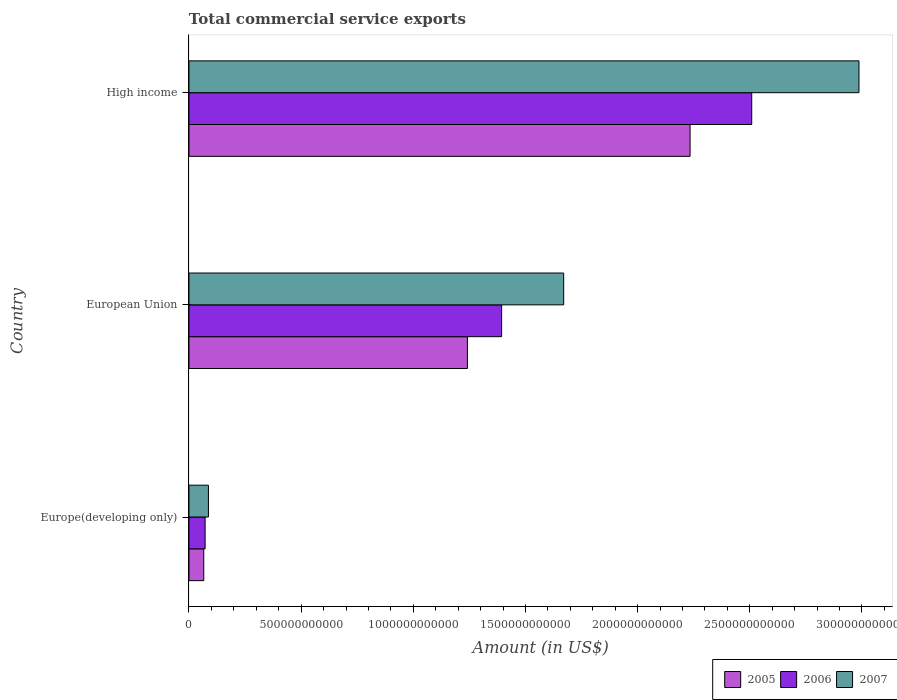Are the number of bars on each tick of the Y-axis equal?
Make the answer very short. Yes. What is the label of the 2nd group of bars from the top?
Make the answer very short. European Union. In how many cases, is the number of bars for a given country not equal to the number of legend labels?
Offer a terse response. 0. What is the total commercial service exports in 2006 in European Union?
Provide a short and direct response. 1.39e+12. Across all countries, what is the maximum total commercial service exports in 2005?
Provide a short and direct response. 2.23e+12. Across all countries, what is the minimum total commercial service exports in 2007?
Your answer should be very brief. 8.67e+1. In which country was the total commercial service exports in 2007 minimum?
Make the answer very short. Europe(developing only). What is the total total commercial service exports in 2006 in the graph?
Offer a very short reply. 3.97e+12. What is the difference between the total commercial service exports in 2005 in Europe(developing only) and that in High income?
Your answer should be compact. -2.17e+12. What is the difference between the total commercial service exports in 2005 in Europe(developing only) and the total commercial service exports in 2007 in High income?
Make the answer very short. -2.92e+12. What is the average total commercial service exports in 2007 per country?
Keep it short and to the point. 1.58e+12. What is the difference between the total commercial service exports in 2005 and total commercial service exports in 2006 in Europe(developing only)?
Make the answer very short. -6.08e+09. What is the ratio of the total commercial service exports in 2005 in Europe(developing only) to that in High income?
Keep it short and to the point. 0.03. Is the total commercial service exports in 2007 in European Union less than that in High income?
Your answer should be very brief. Yes. Is the difference between the total commercial service exports in 2005 in European Union and High income greater than the difference between the total commercial service exports in 2006 in European Union and High income?
Your answer should be very brief. Yes. What is the difference between the highest and the second highest total commercial service exports in 2006?
Give a very brief answer. 1.11e+12. What is the difference between the highest and the lowest total commercial service exports in 2007?
Provide a succinct answer. 2.90e+12. In how many countries, is the total commercial service exports in 2006 greater than the average total commercial service exports in 2006 taken over all countries?
Make the answer very short. 2. What does the 1st bar from the bottom in High income represents?
Your answer should be compact. 2005. Is it the case that in every country, the sum of the total commercial service exports in 2006 and total commercial service exports in 2007 is greater than the total commercial service exports in 2005?
Your answer should be very brief. Yes. What is the difference between two consecutive major ticks on the X-axis?
Offer a terse response. 5.00e+11. Does the graph contain any zero values?
Give a very brief answer. No. Does the graph contain grids?
Give a very brief answer. No. Where does the legend appear in the graph?
Your answer should be compact. Bottom right. How many legend labels are there?
Offer a very short reply. 3. What is the title of the graph?
Keep it short and to the point. Total commercial service exports. Does "1998" appear as one of the legend labels in the graph?
Your response must be concise. No. What is the label or title of the X-axis?
Provide a short and direct response. Amount (in US$). What is the Amount (in US$) in 2005 in Europe(developing only)?
Your answer should be compact. 6.59e+1. What is the Amount (in US$) in 2006 in Europe(developing only)?
Ensure brevity in your answer.  7.19e+1. What is the Amount (in US$) of 2007 in Europe(developing only)?
Offer a very short reply. 8.67e+1. What is the Amount (in US$) of 2005 in European Union?
Keep it short and to the point. 1.24e+12. What is the Amount (in US$) of 2006 in European Union?
Provide a short and direct response. 1.39e+12. What is the Amount (in US$) of 2007 in European Union?
Give a very brief answer. 1.67e+12. What is the Amount (in US$) of 2005 in High income?
Provide a short and direct response. 2.23e+12. What is the Amount (in US$) in 2006 in High income?
Your answer should be very brief. 2.51e+12. What is the Amount (in US$) in 2007 in High income?
Your answer should be very brief. 2.99e+12. Across all countries, what is the maximum Amount (in US$) of 2005?
Provide a short and direct response. 2.23e+12. Across all countries, what is the maximum Amount (in US$) in 2006?
Make the answer very short. 2.51e+12. Across all countries, what is the maximum Amount (in US$) of 2007?
Your answer should be very brief. 2.99e+12. Across all countries, what is the minimum Amount (in US$) in 2005?
Make the answer very short. 6.59e+1. Across all countries, what is the minimum Amount (in US$) of 2006?
Provide a short and direct response. 7.19e+1. Across all countries, what is the minimum Amount (in US$) of 2007?
Ensure brevity in your answer.  8.67e+1. What is the total Amount (in US$) of 2005 in the graph?
Offer a terse response. 3.54e+12. What is the total Amount (in US$) of 2006 in the graph?
Your response must be concise. 3.97e+12. What is the total Amount (in US$) of 2007 in the graph?
Your answer should be compact. 4.74e+12. What is the difference between the Amount (in US$) of 2005 in Europe(developing only) and that in European Union?
Provide a short and direct response. -1.18e+12. What is the difference between the Amount (in US$) in 2006 in Europe(developing only) and that in European Union?
Provide a succinct answer. -1.32e+12. What is the difference between the Amount (in US$) in 2007 in Europe(developing only) and that in European Union?
Offer a terse response. -1.58e+12. What is the difference between the Amount (in US$) in 2005 in Europe(developing only) and that in High income?
Your answer should be compact. -2.17e+12. What is the difference between the Amount (in US$) in 2006 in Europe(developing only) and that in High income?
Your answer should be very brief. -2.44e+12. What is the difference between the Amount (in US$) in 2007 in Europe(developing only) and that in High income?
Provide a short and direct response. -2.90e+12. What is the difference between the Amount (in US$) in 2005 in European Union and that in High income?
Ensure brevity in your answer.  -9.93e+11. What is the difference between the Amount (in US$) in 2006 in European Union and that in High income?
Offer a very short reply. -1.11e+12. What is the difference between the Amount (in US$) of 2007 in European Union and that in High income?
Ensure brevity in your answer.  -1.32e+12. What is the difference between the Amount (in US$) in 2005 in Europe(developing only) and the Amount (in US$) in 2006 in European Union?
Give a very brief answer. -1.33e+12. What is the difference between the Amount (in US$) in 2005 in Europe(developing only) and the Amount (in US$) in 2007 in European Union?
Offer a terse response. -1.60e+12. What is the difference between the Amount (in US$) in 2006 in Europe(developing only) and the Amount (in US$) in 2007 in European Union?
Ensure brevity in your answer.  -1.60e+12. What is the difference between the Amount (in US$) of 2005 in Europe(developing only) and the Amount (in US$) of 2006 in High income?
Provide a succinct answer. -2.44e+12. What is the difference between the Amount (in US$) in 2005 in Europe(developing only) and the Amount (in US$) in 2007 in High income?
Offer a terse response. -2.92e+12. What is the difference between the Amount (in US$) of 2006 in Europe(developing only) and the Amount (in US$) of 2007 in High income?
Offer a terse response. -2.91e+12. What is the difference between the Amount (in US$) of 2005 in European Union and the Amount (in US$) of 2006 in High income?
Provide a short and direct response. -1.27e+12. What is the difference between the Amount (in US$) in 2005 in European Union and the Amount (in US$) in 2007 in High income?
Keep it short and to the point. -1.75e+12. What is the difference between the Amount (in US$) of 2006 in European Union and the Amount (in US$) of 2007 in High income?
Your answer should be compact. -1.59e+12. What is the average Amount (in US$) in 2005 per country?
Offer a very short reply. 1.18e+12. What is the average Amount (in US$) in 2006 per country?
Your answer should be compact. 1.32e+12. What is the average Amount (in US$) in 2007 per country?
Offer a very short reply. 1.58e+12. What is the difference between the Amount (in US$) in 2005 and Amount (in US$) in 2006 in Europe(developing only)?
Provide a succinct answer. -6.08e+09. What is the difference between the Amount (in US$) of 2005 and Amount (in US$) of 2007 in Europe(developing only)?
Ensure brevity in your answer.  -2.09e+1. What is the difference between the Amount (in US$) of 2006 and Amount (in US$) of 2007 in Europe(developing only)?
Offer a very short reply. -1.48e+1. What is the difference between the Amount (in US$) of 2005 and Amount (in US$) of 2006 in European Union?
Keep it short and to the point. -1.53e+11. What is the difference between the Amount (in US$) in 2005 and Amount (in US$) in 2007 in European Union?
Your answer should be compact. -4.29e+11. What is the difference between the Amount (in US$) in 2006 and Amount (in US$) in 2007 in European Union?
Make the answer very short. -2.77e+11. What is the difference between the Amount (in US$) in 2005 and Amount (in US$) in 2006 in High income?
Provide a succinct answer. -2.75e+11. What is the difference between the Amount (in US$) of 2005 and Amount (in US$) of 2007 in High income?
Provide a short and direct response. -7.53e+11. What is the difference between the Amount (in US$) of 2006 and Amount (in US$) of 2007 in High income?
Ensure brevity in your answer.  -4.78e+11. What is the ratio of the Amount (in US$) of 2005 in Europe(developing only) to that in European Union?
Your response must be concise. 0.05. What is the ratio of the Amount (in US$) of 2006 in Europe(developing only) to that in European Union?
Keep it short and to the point. 0.05. What is the ratio of the Amount (in US$) of 2007 in Europe(developing only) to that in European Union?
Give a very brief answer. 0.05. What is the ratio of the Amount (in US$) in 2005 in Europe(developing only) to that in High income?
Offer a terse response. 0.03. What is the ratio of the Amount (in US$) in 2006 in Europe(developing only) to that in High income?
Your answer should be compact. 0.03. What is the ratio of the Amount (in US$) in 2007 in Europe(developing only) to that in High income?
Ensure brevity in your answer.  0.03. What is the ratio of the Amount (in US$) of 2005 in European Union to that in High income?
Provide a succinct answer. 0.56. What is the ratio of the Amount (in US$) of 2006 in European Union to that in High income?
Ensure brevity in your answer.  0.56. What is the ratio of the Amount (in US$) in 2007 in European Union to that in High income?
Provide a short and direct response. 0.56. What is the difference between the highest and the second highest Amount (in US$) in 2005?
Your answer should be compact. 9.93e+11. What is the difference between the highest and the second highest Amount (in US$) of 2006?
Ensure brevity in your answer.  1.11e+12. What is the difference between the highest and the second highest Amount (in US$) of 2007?
Your response must be concise. 1.32e+12. What is the difference between the highest and the lowest Amount (in US$) in 2005?
Provide a succinct answer. 2.17e+12. What is the difference between the highest and the lowest Amount (in US$) in 2006?
Your response must be concise. 2.44e+12. What is the difference between the highest and the lowest Amount (in US$) of 2007?
Offer a very short reply. 2.90e+12. 